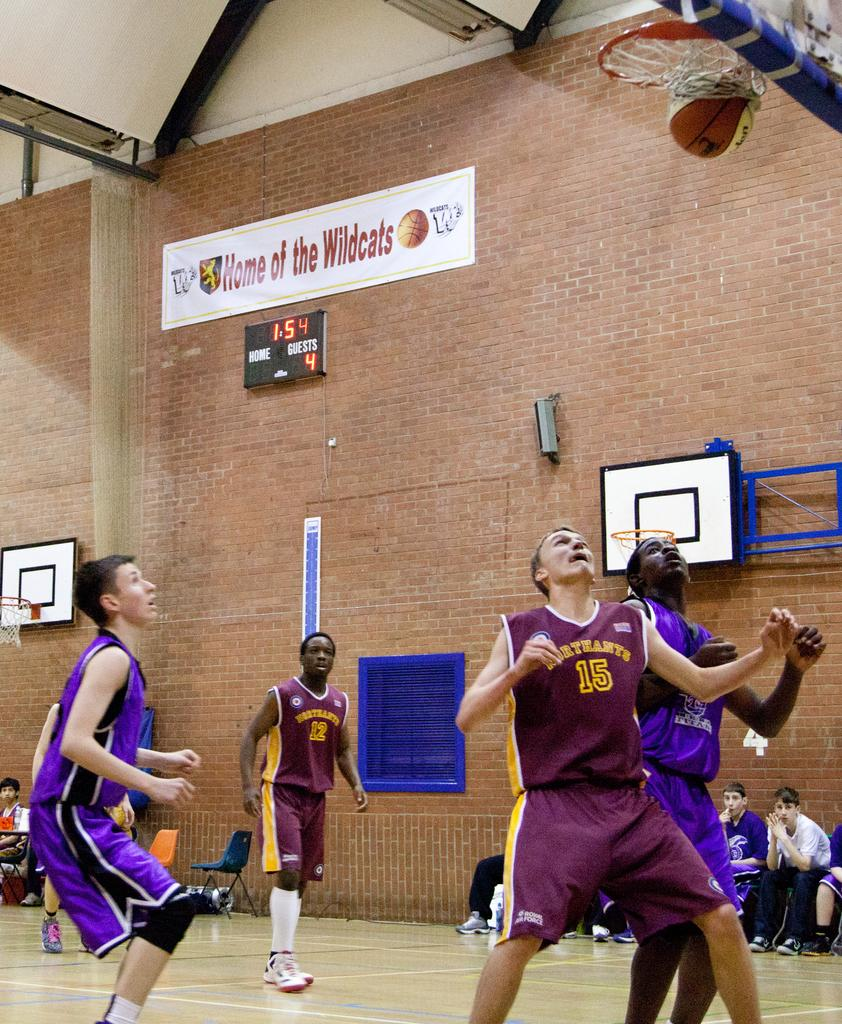<image>
Create a compact narrative representing the image presented. Player number 15 watches a basketball go through a hoop during a game. 